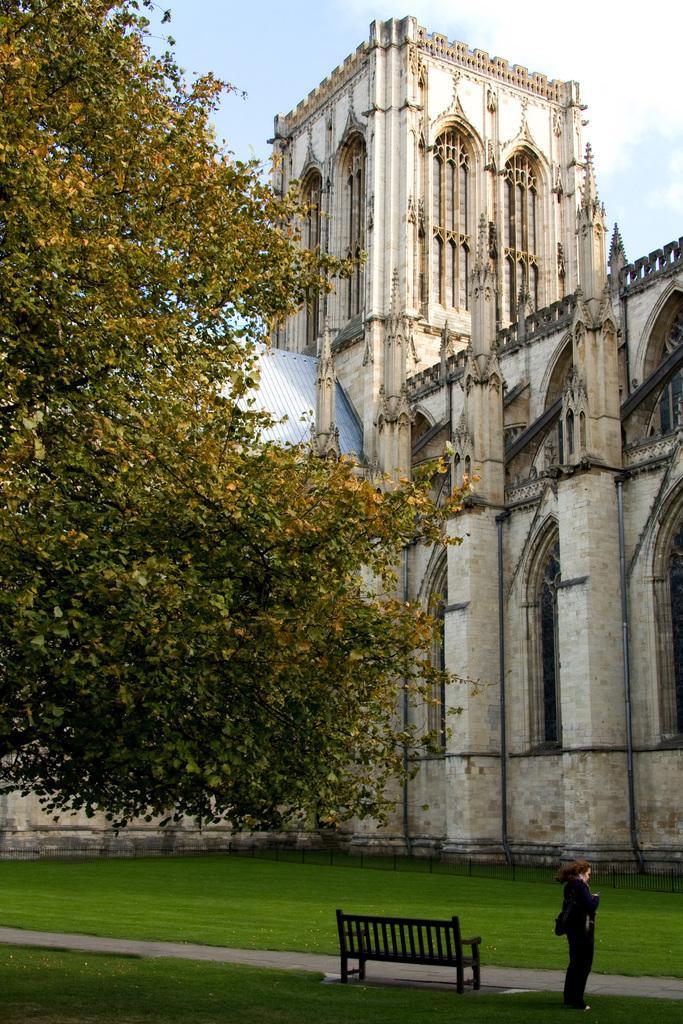Could you give a brief overview of what you see in this image? In this picture I can see there is a woman standing on the right side and there is a bench, there's grass on the floor and there is a building in the backdrop and a tree on the left side. The sky is clear. 